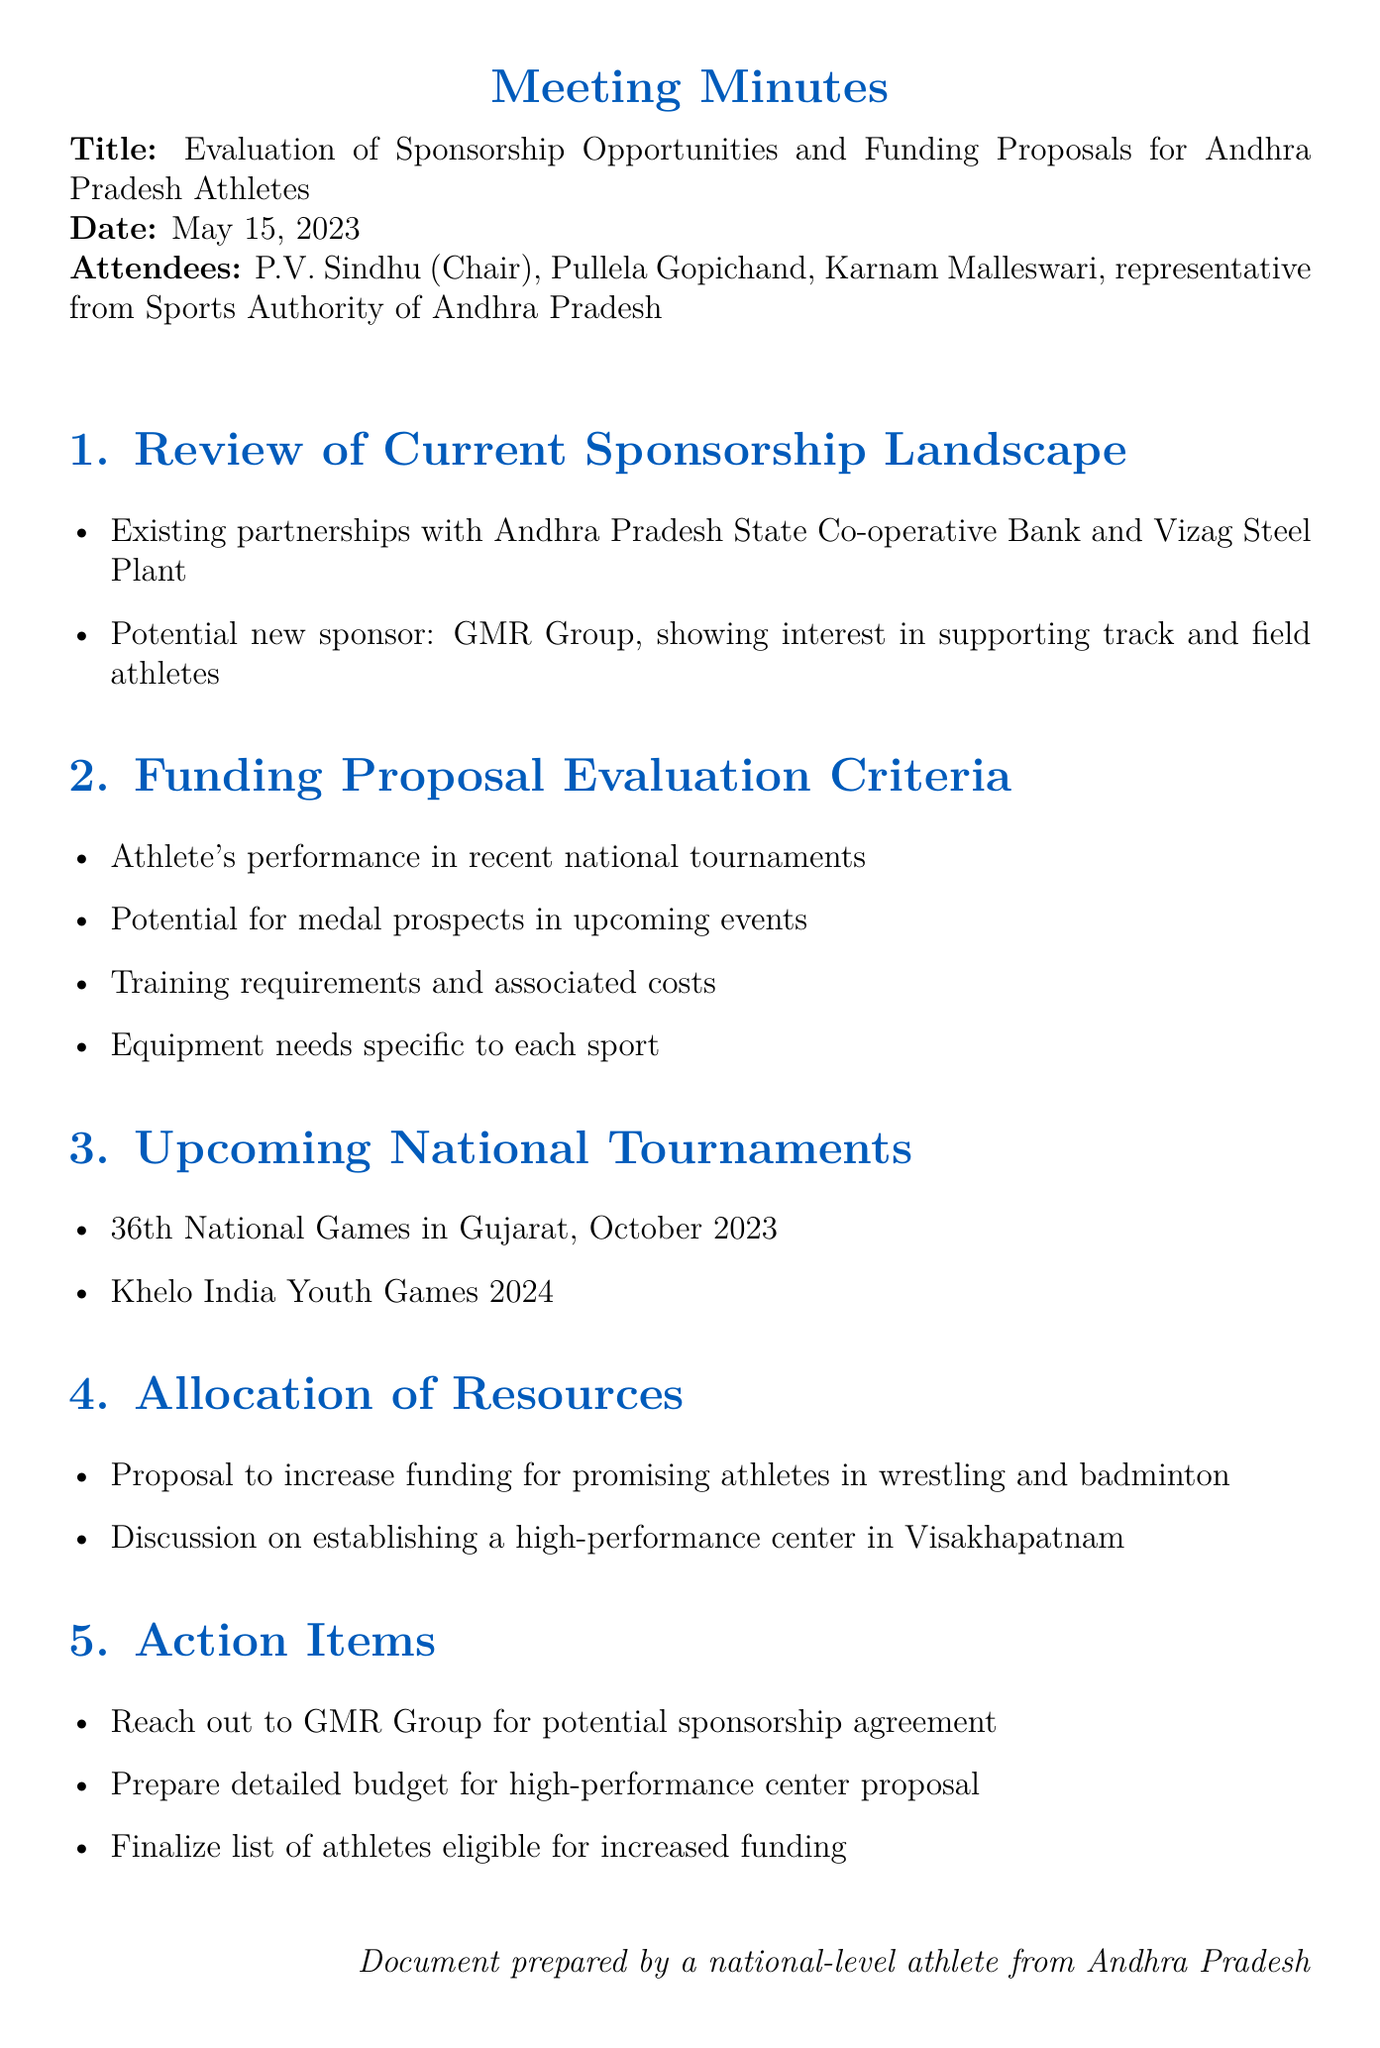what is the title of the meeting? The title is explicitly mentioned at the beginning of the document.
Answer: Evaluation of Sponsorship Opportunities and Funding Proposals for Andhra Pradesh Athletes who chaired the meeting? The chair of the meeting is specified in the attendees list.
Answer: P.V. Sindhu when is the 36th National Games scheduled? The document lists the date of this event under upcoming tournaments.
Answer: October 2023 which organization has shown interest in sponsoring track and field athletes? The potential sponsor is mentioned in the sponsorship landscape review.
Answer: GMR Group what criteria are considered for funding proposal evaluation? The criteria are listed under the funding proposal evaluation section.
Answer: Athlete's performance in recent national tournaments, potential for medal prospects in upcoming events, training requirements and associated costs, equipment needs specific to each sport which two sports are proposed to receive increased funding? The specific sports are mentioned under the allocation of resources section.
Answer: Wrestling and badminton what is one action item from the meeting? The action items are listed at the end of the document.
Answer: Reach out to GMR Group for potential sponsorship agreement who is a representative attendee from the Sports Authority? The document names all attendees, including that role.
Answer: representative from Sports Authority of Andhra Pradesh 